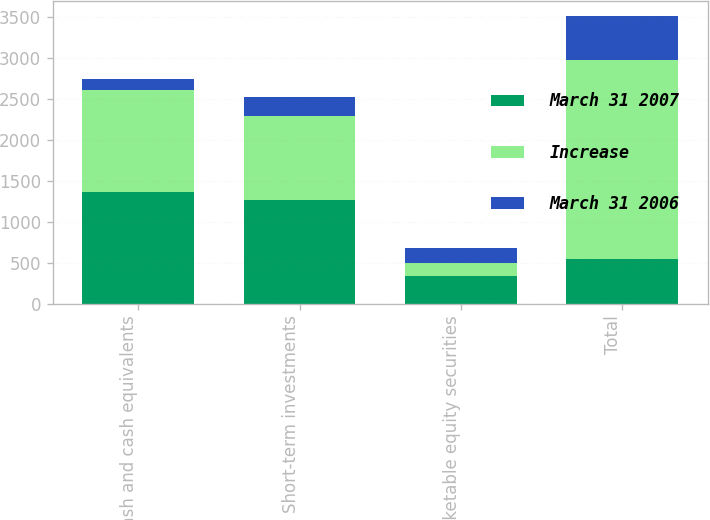Convert chart to OTSL. <chart><loc_0><loc_0><loc_500><loc_500><stacked_bar_chart><ecel><fcel>Cash and cash equivalents<fcel>Short-term investments<fcel>Marketable equity securities<fcel>Total<nl><fcel>March 31 2007<fcel>1371<fcel>1264<fcel>341<fcel>544<nl><fcel>Increase<fcel>1242<fcel>1030<fcel>160<fcel>2432<nl><fcel>March 31 2006<fcel>129<fcel>234<fcel>181<fcel>544<nl></chart> 